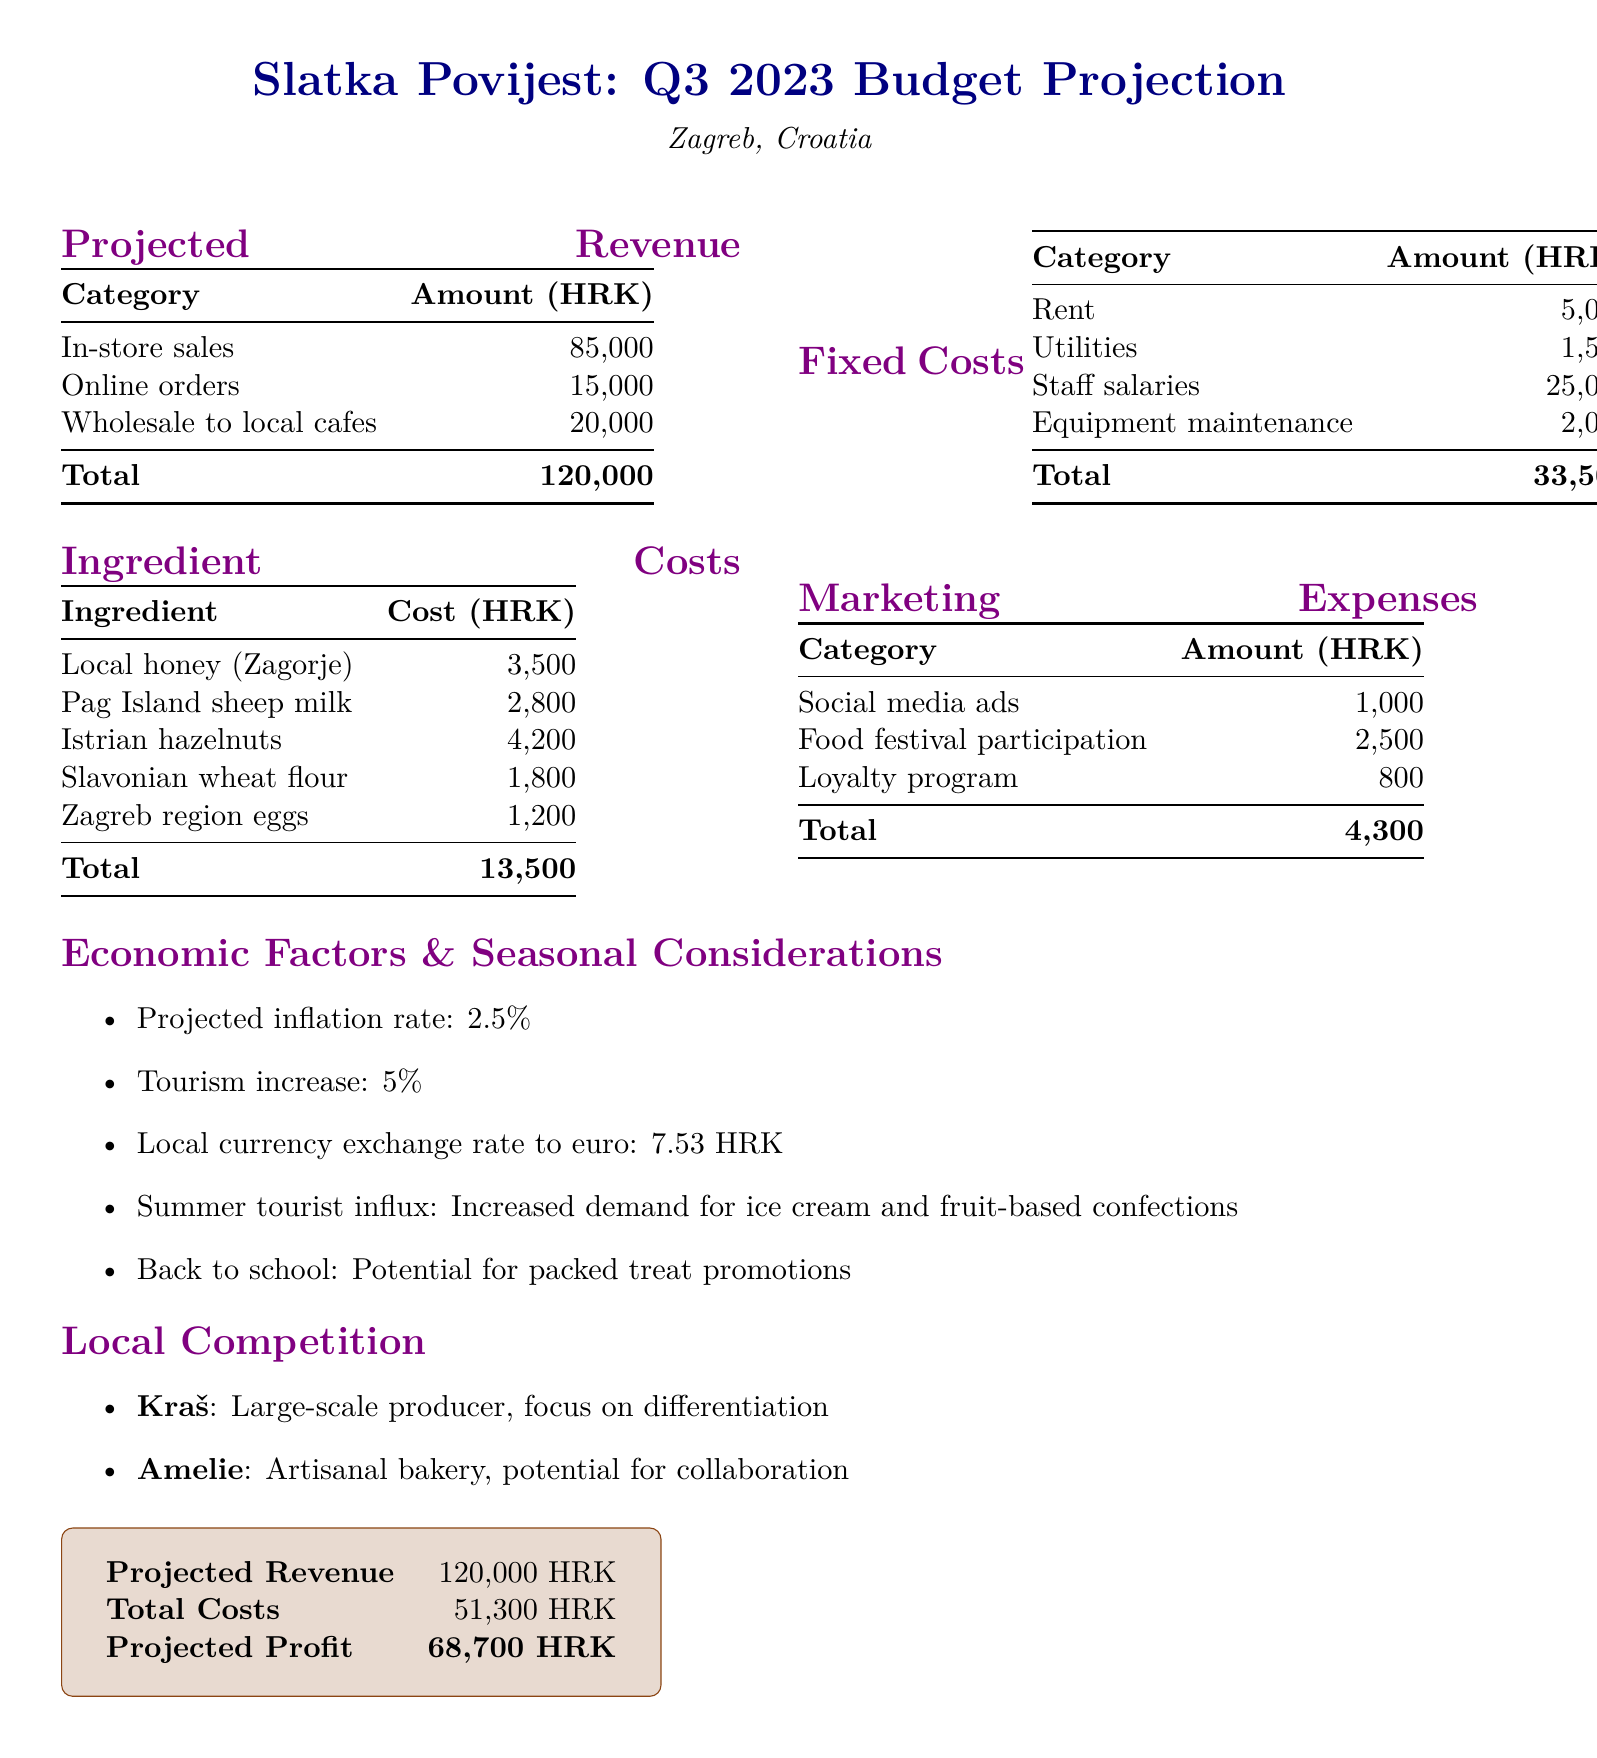What is the total projected revenue? The total projected revenue is calculated by summing the amounts from in-store sales, online orders, and wholesale to local cafes, which equals 85000 + 15000 + 20000 = 120000 HRK.
Answer: 120000 HRK What are the ingredient costs? The ingredient costs are detailed in the table, which shows local honey, sheep milk, hazelnuts, wheat flour, and eggs totaling 13500 HRK.
Answer: 13500 HRK What is the total fixed cost? The total fixed cost is derived from the sum of rent, utilities, staff salaries, and equipment maintenance, totaling 5000 + 1500 + 25000 + 2000 = 33500 HRK.
Answer: 33500 HRK What local ingredient costs the most? Among the listed ingredients, Istrian hazelnuts have the highest cost of 4200 HRK.
Answer: Istrian hazelnuts What is the projected profit? The projected profit is determined by subtracting total costs from projected revenue, which is 120000 - 51300 = 68700 HRK.
Answer: 68700 HRK What is the marketing expense for social media ads? The document specifies the amount allocated for social media ads as 1000 HRK.
Answer: 1000 HRK What is the projected inflation rate? The projected inflation rate mentioned in the document is 2.5%.
Answer: 2.5% Who are the local competitors mentioned? The document lists Kraš and Amelie as local competitors in the confectionery market.
Answer: Kraš and Amelie What seasonal consideration is mentioned for potential sales? The document notes the summer tourist influx as a seasonal consideration that may increase demand for certain confectionery items.
Answer: Summer tourist influx 